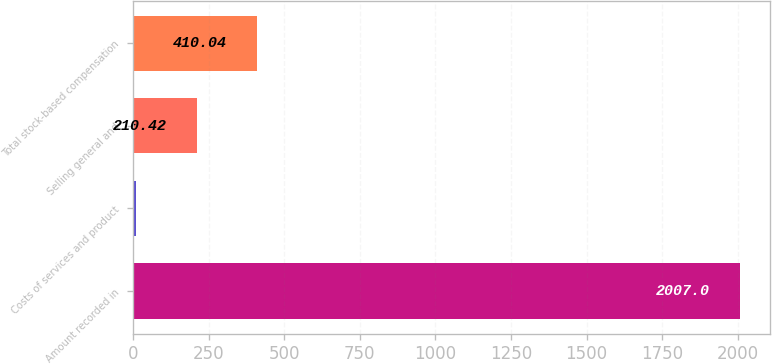Convert chart. <chart><loc_0><loc_0><loc_500><loc_500><bar_chart><fcel>Amount recorded in<fcel>Costs of services and product<fcel>Selling general and<fcel>Total stock-based compensation<nl><fcel>2007<fcel>10.8<fcel>210.42<fcel>410.04<nl></chart> 